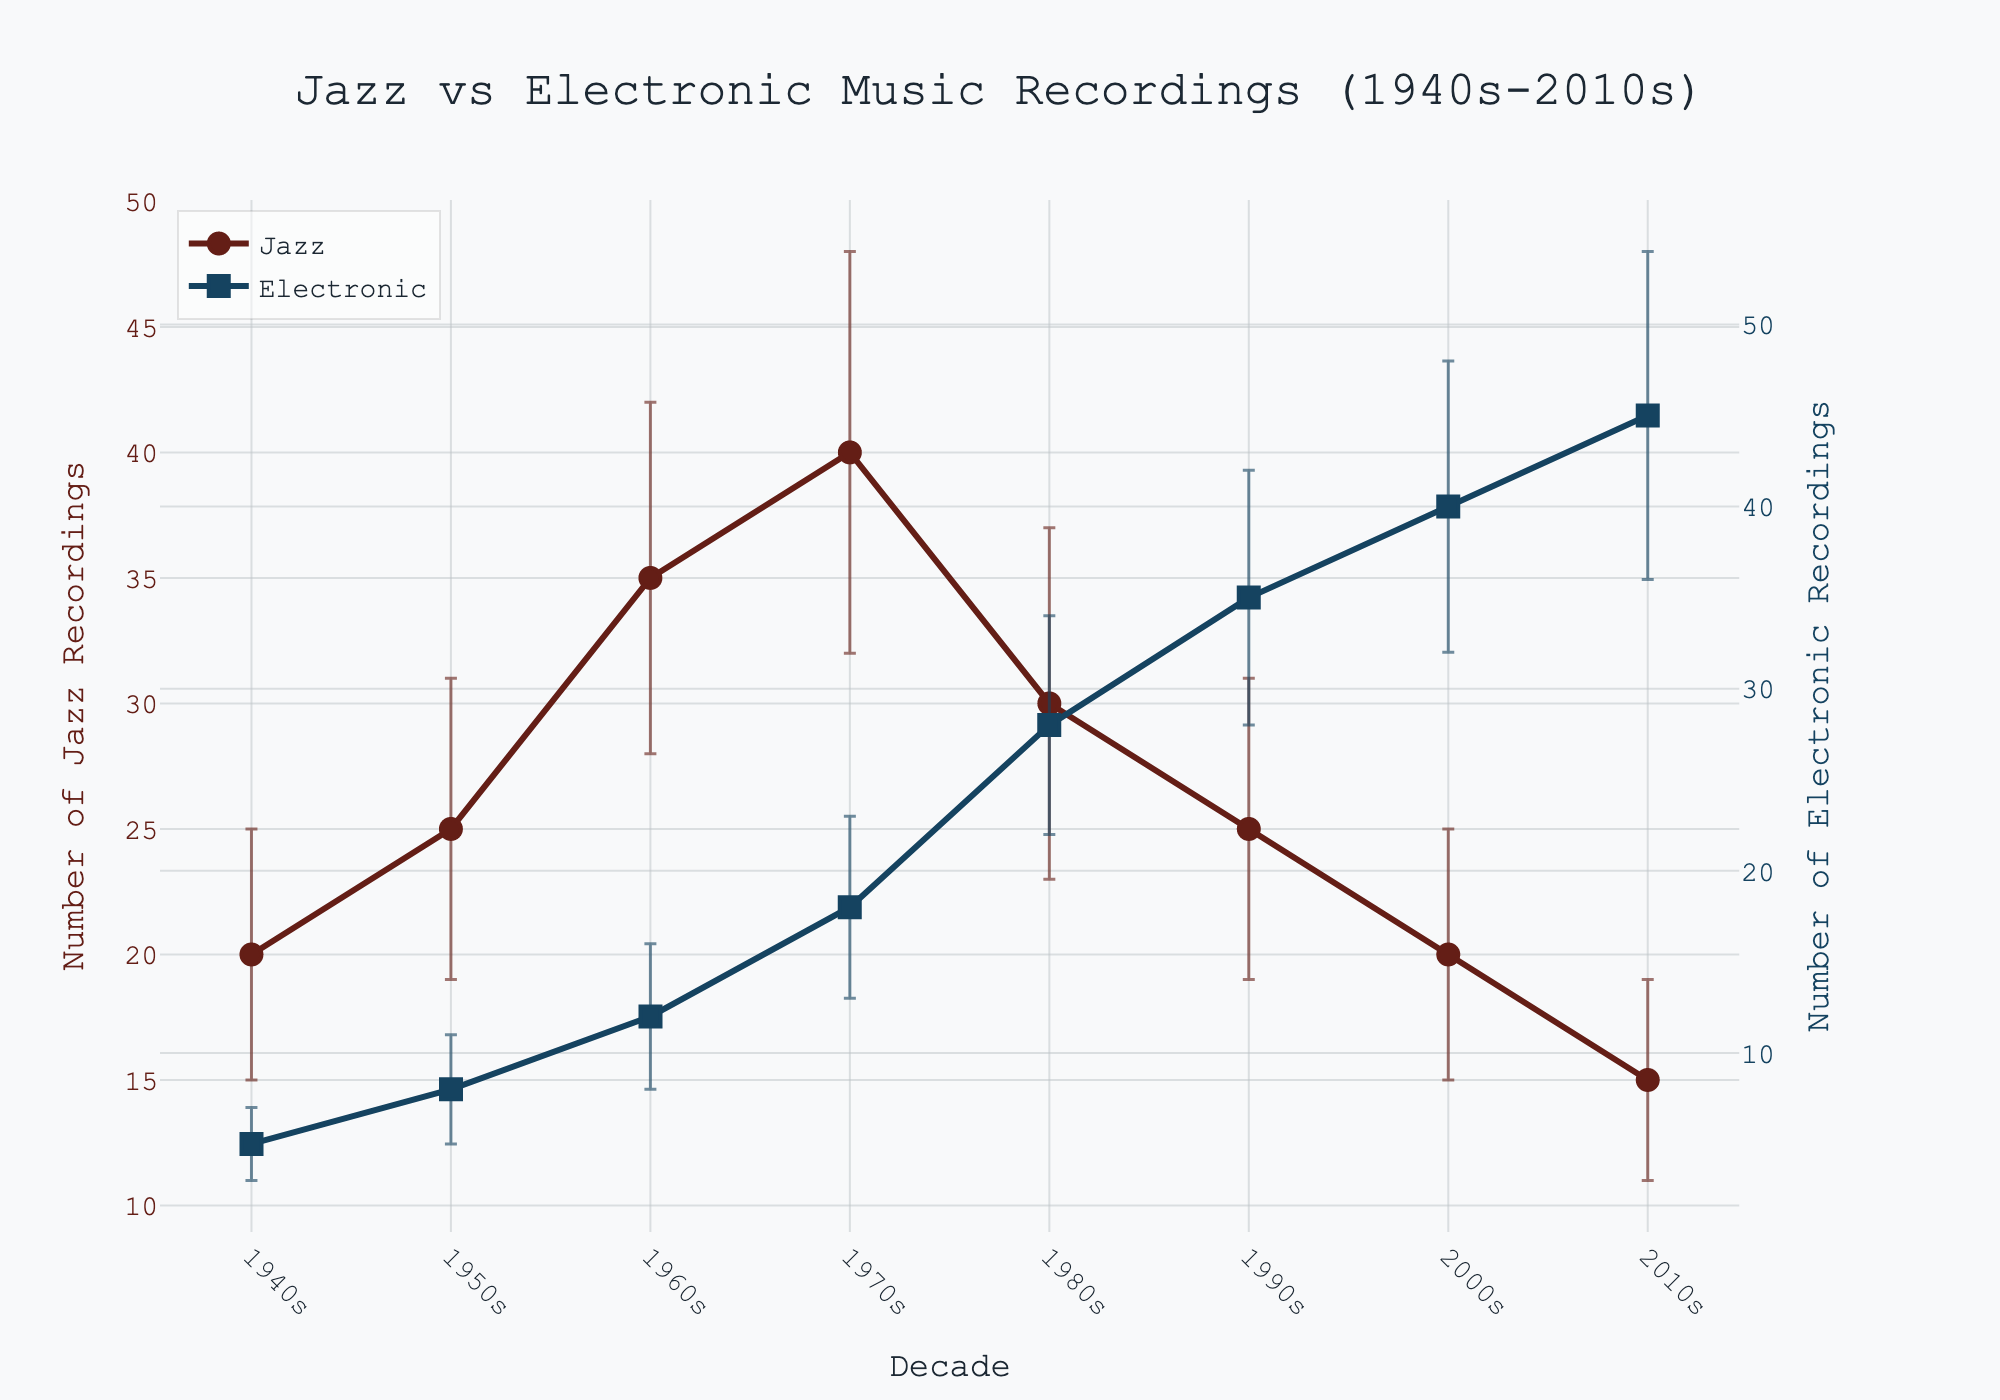what is the title of the figure? The title is located at the top center of the figure and it states the main focus of the plot.
Answer: Jazz vs Electronic Music Recordings (1940s-2010s) What color are the markers for Jazz recordings? Jazz recordings use circles as markers, and the color of these markers is a shade of dark red.
Answer: Dark red In which decade did jazz recordings peak? By looking at the highest point on the Jazz line, we can see that the peak occurs in the 1970s.
Answer: 1970s During which decade did electronic music recordings surpass jazz recordings? By comparing the lines, electronic music recordings surpass jazz recordings starting from the 1980s to the 2010s.
Answer: 1980s What is the range of the number of electronic music recordings in the 2000s? For this, we take the mean (40) and add/subtract the standard deviation (8) to get the range: [32, 48].
Answer: [32, 48] Which genre had a higher variability in the 1980s? Compare the standard deviations for the 1980s: Jazz (7) and Electronic (6).
Answer: Jazz How did the trend of electronic music recordings change from the 1940s to the 2010s? The trend for electronic music recordings shows a steady increase from the 1940s to the 2010s.
Answer: Steady increase In which decades did jazz have more than double the mean recordings of electronic music? Compare the mean recordings of jazz and electronic across decades to find when jazz had more than twice the recordings. This occurs in the 1940s, 1950s, and 1960s.
Answer: 1940s, 1950s, 1960s Compare the error bars of jazz and electronic music in the 1970s. The error bars for both jazz and electronic music in the 1970s seem to overlap to some extent, but jazz's error bar covers a wider range since the standard deviation is 8 while electronic music has a standard deviation of 5.
Answer: Jazz has a wider range 